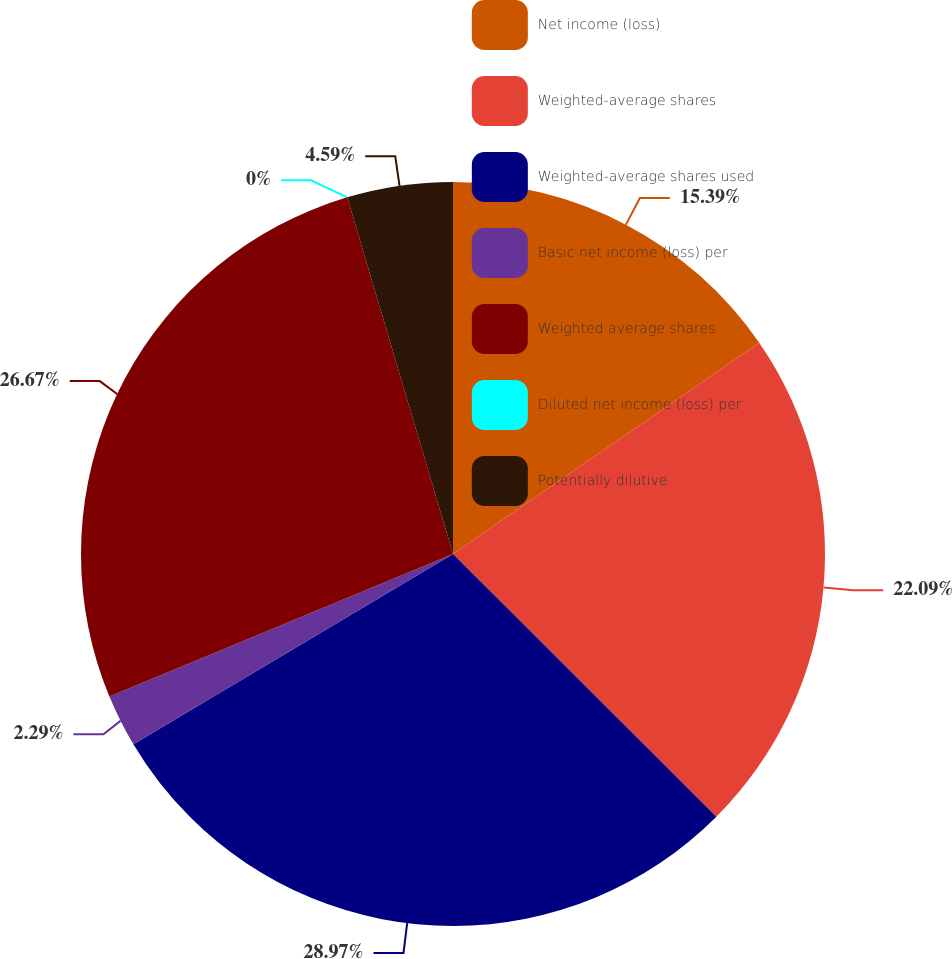Convert chart to OTSL. <chart><loc_0><loc_0><loc_500><loc_500><pie_chart><fcel>Net income (loss)<fcel>Weighted-average shares<fcel>Weighted-average shares used<fcel>Basic net income (loss) per<fcel>Weighted average shares<fcel>Diluted net income (loss) per<fcel>Potentially dilutive<nl><fcel>15.39%<fcel>22.09%<fcel>28.97%<fcel>2.29%<fcel>26.67%<fcel>0.0%<fcel>4.59%<nl></chart> 